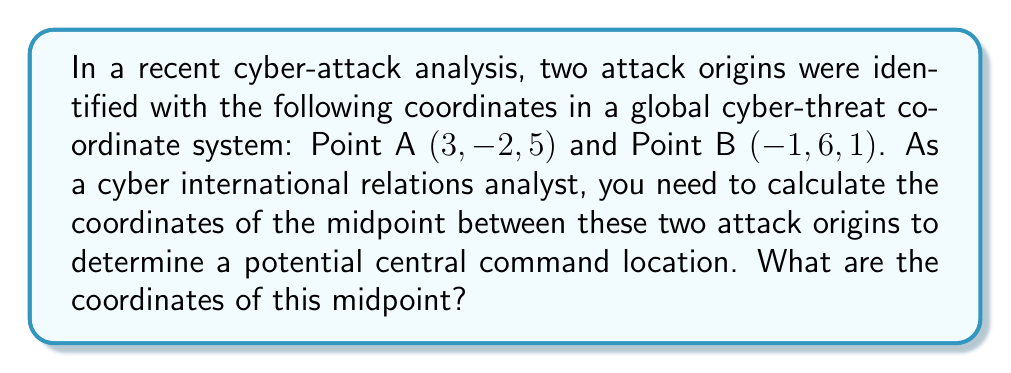Solve this math problem. To solve this problem, we'll use the midpoint formula in three-dimensional space. The midpoint formula for two points $(x_1, y_1, z_1)$ and $(x_2, y_2, z_2)$ is:

$$\left(\frac{x_1 + x_2}{2}, \frac{y_1 + y_2}{2}, \frac{z_1 + z_2}{2}\right)$$

Let's apply this formula to our given points:

Point A: $(3, -2, 5)$
Point B: $(-1, 6, 1)$

1. Calculate the x-coordinate of the midpoint:
   $$\frac{x_1 + x_2}{2} = \frac{3 + (-1)}{2} = \frac{2}{2} = 1$$

2. Calculate the y-coordinate of the midpoint:
   $$\frac{y_1 + y_2}{2} = \frac{-2 + 6}{2} = \frac{4}{2} = 2$$

3. Calculate the z-coordinate of the midpoint:
   $$\frac{z_1 + z_2}{2} = \frac{5 + 1}{2} = \frac{6}{2} = 3$$

Therefore, the coordinates of the midpoint are $(1, 2, 3)$.
Answer: The coordinates of the midpoint between the two attack origins are $(1, 2, 3)$. 